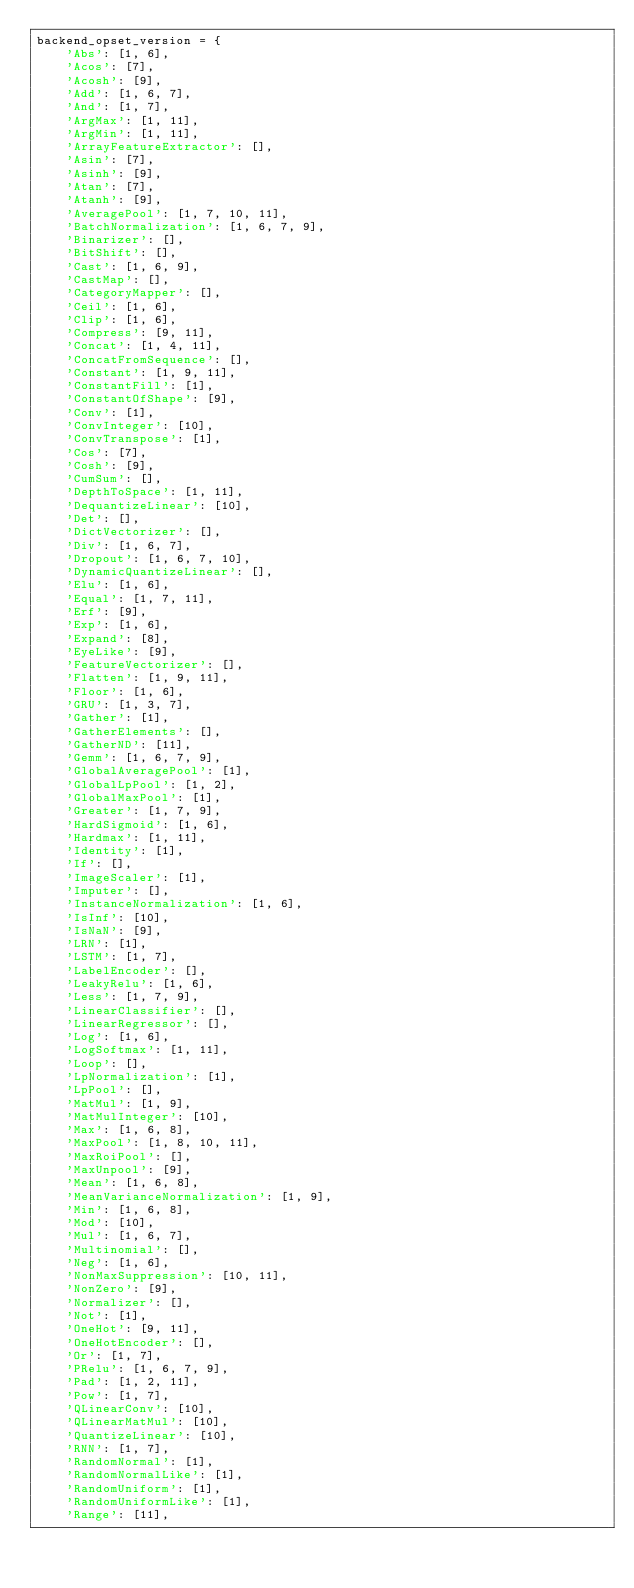<code> <loc_0><loc_0><loc_500><loc_500><_Python_>backend_opset_version = {
    'Abs': [1, 6],
    'Acos': [7],
    'Acosh': [9],
    'Add': [1, 6, 7],
    'And': [1, 7],
    'ArgMax': [1, 11],
    'ArgMin': [1, 11],
    'ArrayFeatureExtractor': [],
    'Asin': [7],
    'Asinh': [9],
    'Atan': [7],
    'Atanh': [9],
    'AveragePool': [1, 7, 10, 11],
    'BatchNormalization': [1, 6, 7, 9],
    'Binarizer': [],
    'BitShift': [],
    'Cast': [1, 6, 9],
    'CastMap': [],
    'CategoryMapper': [],
    'Ceil': [1, 6],
    'Clip': [1, 6],
    'Compress': [9, 11],
    'Concat': [1, 4, 11],
    'ConcatFromSequence': [],
    'Constant': [1, 9, 11],
    'ConstantFill': [1],
    'ConstantOfShape': [9],
    'Conv': [1],
    'ConvInteger': [10],
    'ConvTranspose': [1],
    'Cos': [7],
    'Cosh': [9],
    'CumSum': [],
    'DepthToSpace': [1, 11],
    'DequantizeLinear': [10],
    'Det': [],
    'DictVectorizer': [],
    'Div': [1, 6, 7],
    'Dropout': [1, 6, 7, 10],
    'DynamicQuantizeLinear': [],
    'Elu': [1, 6],
    'Equal': [1, 7, 11],
    'Erf': [9],
    'Exp': [1, 6],
    'Expand': [8],
    'EyeLike': [9],
    'FeatureVectorizer': [],
    'Flatten': [1, 9, 11],
    'Floor': [1, 6],
    'GRU': [1, 3, 7],
    'Gather': [1],
    'GatherElements': [],
    'GatherND': [11],
    'Gemm': [1, 6, 7, 9],
    'GlobalAveragePool': [1],
    'GlobalLpPool': [1, 2],
    'GlobalMaxPool': [1],
    'Greater': [1, 7, 9],
    'HardSigmoid': [1, 6],
    'Hardmax': [1, 11],
    'Identity': [1],
    'If': [],
    'ImageScaler': [1],
    'Imputer': [],
    'InstanceNormalization': [1, 6],
    'IsInf': [10],
    'IsNaN': [9],
    'LRN': [1],
    'LSTM': [1, 7],
    'LabelEncoder': [],
    'LeakyRelu': [1, 6],
    'Less': [1, 7, 9],
    'LinearClassifier': [],
    'LinearRegressor': [],
    'Log': [1, 6],
    'LogSoftmax': [1, 11],
    'Loop': [],
    'LpNormalization': [1],
    'LpPool': [],
    'MatMul': [1, 9],
    'MatMulInteger': [10],
    'Max': [1, 6, 8],
    'MaxPool': [1, 8, 10, 11],
    'MaxRoiPool': [],
    'MaxUnpool': [9],
    'Mean': [1, 6, 8],
    'MeanVarianceNormalization': [1, 9],
    'Min': [1, 6, 8],
    'Mod': [10],
    'Mul': [1, 6, 7],
    'Multinomial': [],
    'Neg': [1, 6],
    'NonMaxSuppression': [10, 11],
    'NonZero': [9],
    'Normalizer': [],
    'Not': [1],
    'OneHot': [9, 11],
    'OneHotEncoder': [],
    'Or': [1, 7],
    'PRelu': [1, 6, 7, 9],
    'Pad': [1, 2, 11],
    'Pow': [1, 7],
    'QLinearConv': [10],
    'QLinearMatMul': [10],
    'QuantizeLinear': [10],
    'RNN': [1, 7],
    'RandomNormal': [1],
    'RandomNormalLike': [1],
    'RandomUniform': [1],
    'RandomUniformLike': [1],
    'Range': [11],</code> 